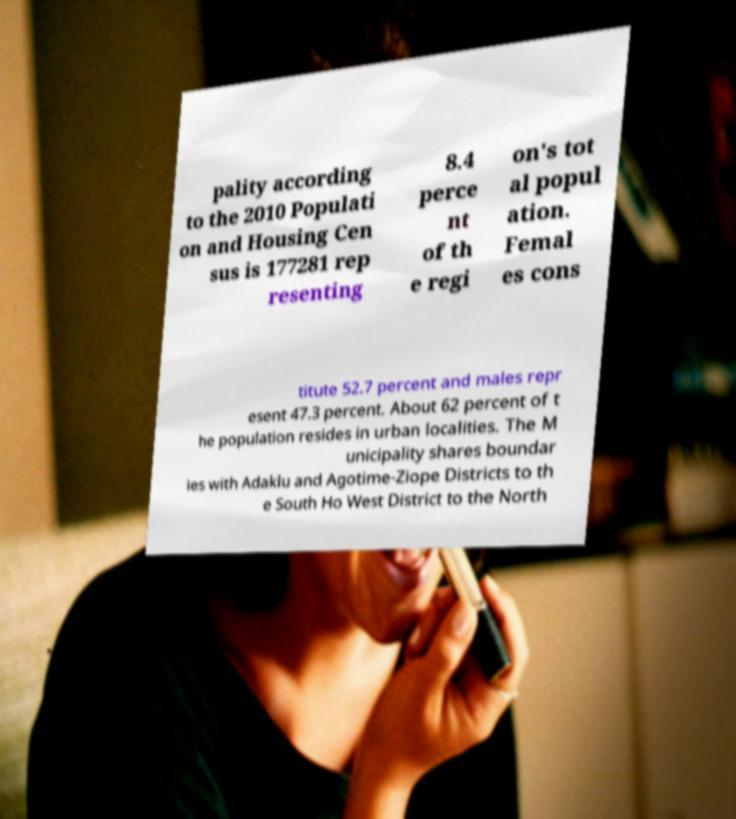Could you extract and type out the text from this image? pality according to the 2010 Populati on and Housing Cen sus is 177281 rep resenting 8.4 perce nt of th e regi on's tot al popul ation. Femal es cons titute 52.7 percent and males repr esent 47.3 percent. About 62 percent of t he population resides in urban localities. The M unicipality shares boundar ies with Adaklu and Agotime-Ziope Districts to th e South Ho West District to the North 